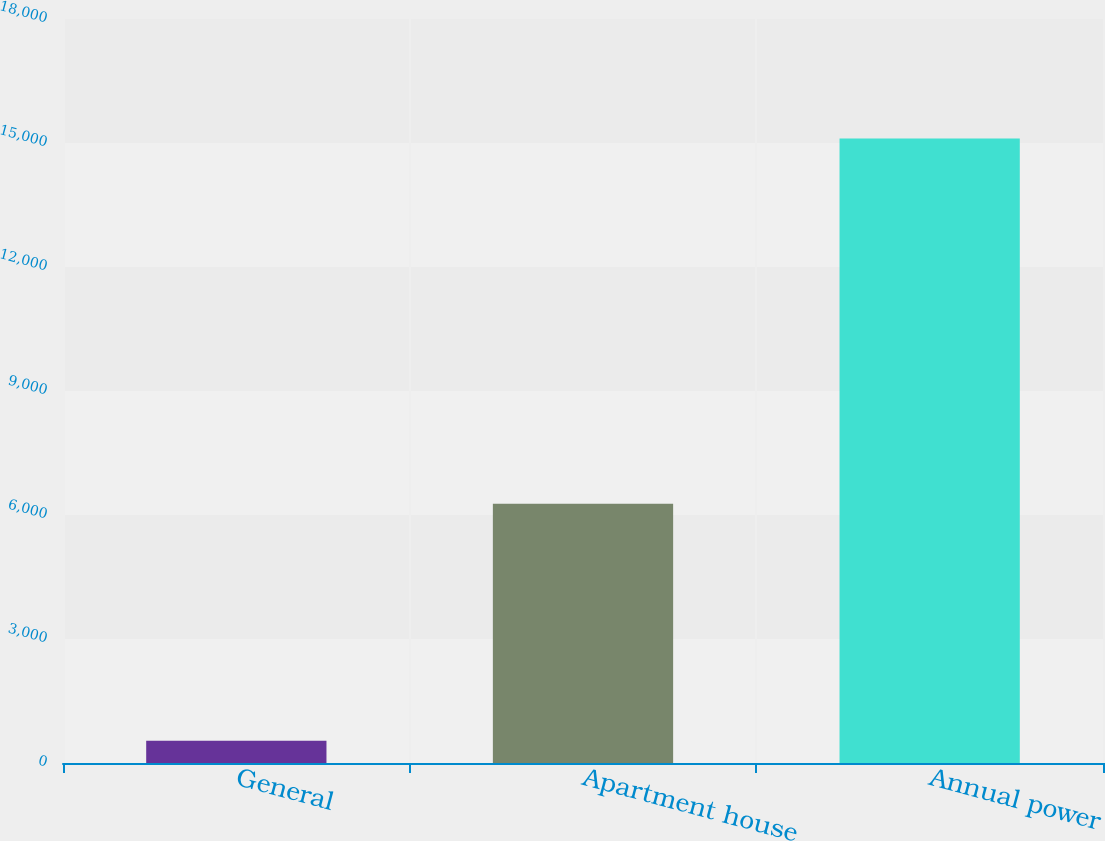Convert chart to OTSL. <chart><loc_0><loc_0><loc_500><loc_500><bar_chart><fcel>General<fcel>Apartment house<fcel>Annual power<nl><fcel>538<fcel>6272<fcel>15109<nl></chart> 